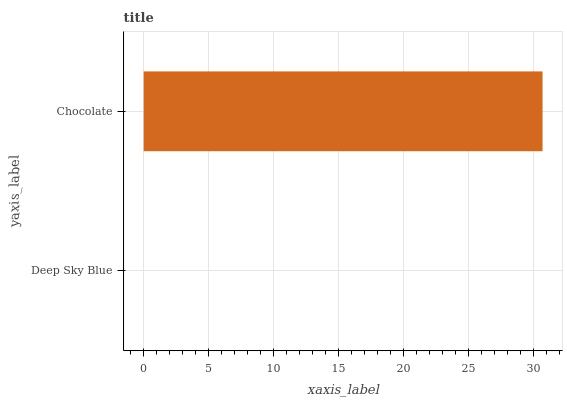Is Deep Sky Blue the minimum?
Answer yes or no. Yes. Is Chocolate the maximum?
Answer yes or no. Yes. Is Chocolate the minimum?
Answer yes or no. No. Is Chocolate greater than Deep Sky Blue?
Answer yes or no. Yes. Is Deep Sky Blue less than Chocolate?
Answer yes or no. Yes. Is Deep Sky Blue greater than Chocolate?
Answer yes or no. No. Is Chocolate less than Deep Sky Blue?
Answer yes or no. No. Is Chocolate the high median?
Answer yes or no. Yes. Is Deep Sky Blue the low median?
Answer yes or no. Yes. Is Deep Sky Blue the high median?
Answer yes or no. No. Is Chocolate the low median?
Answer yes or no. No. 